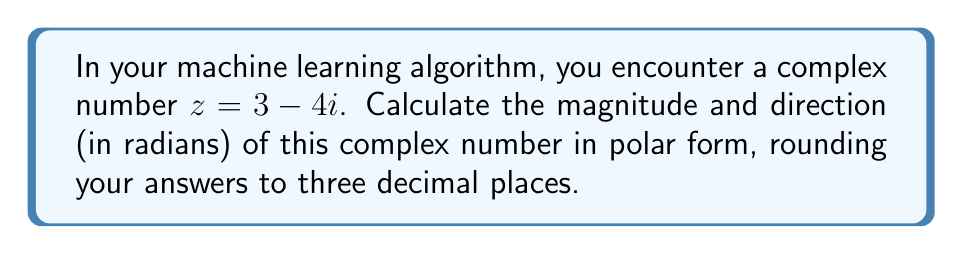What is the answer to this math problem? To convert a complex number from rectangular form $(a + bi)$ to polar form $(r(\cos\theta + i\sin\theta))$, we need to calculate the magnitude $r$ and the direction $\theta$.

Step 1: Calculate the magnitude $r$
The magnitude is given by the formula:
$$r = \sqrt{a^2 + b^2}$$
where $a$ is the real part and $b$ is the imaginary part.

For $z = 3 - 4i$, $a = 3$ and $b = -4$

$$r = \sqrt{3^2 + (-4)^2} = \sqrt{9 + 16} = \sqrt{25} = 5$$

Step 2: Calculate the direction $\theta$
The direction is given by the formula:
$$\theta = \tan^{-1}\left(\frac{b}{a}\right)$$

However, we need to be careful about which quadrant the angle is in. Since the real part is positive and the imaginary part is negative, we're in the fourth quadrant.

$$\theta = \tan^{-1}\left(\frac{-4}{3}\right) = -0.927$$

To get the angle in the correct quadrant, we add $2\pi$ to this value:

$$\theta = -0.927 + 2\pi = 5.356$$

Step 3: Round the results to three decimal places
Magnitude: $r = 5.000$
Direction: $\theta = 5.356$ radians
Answer: $r = 5.000$, $\theta = 5.356$ radians 